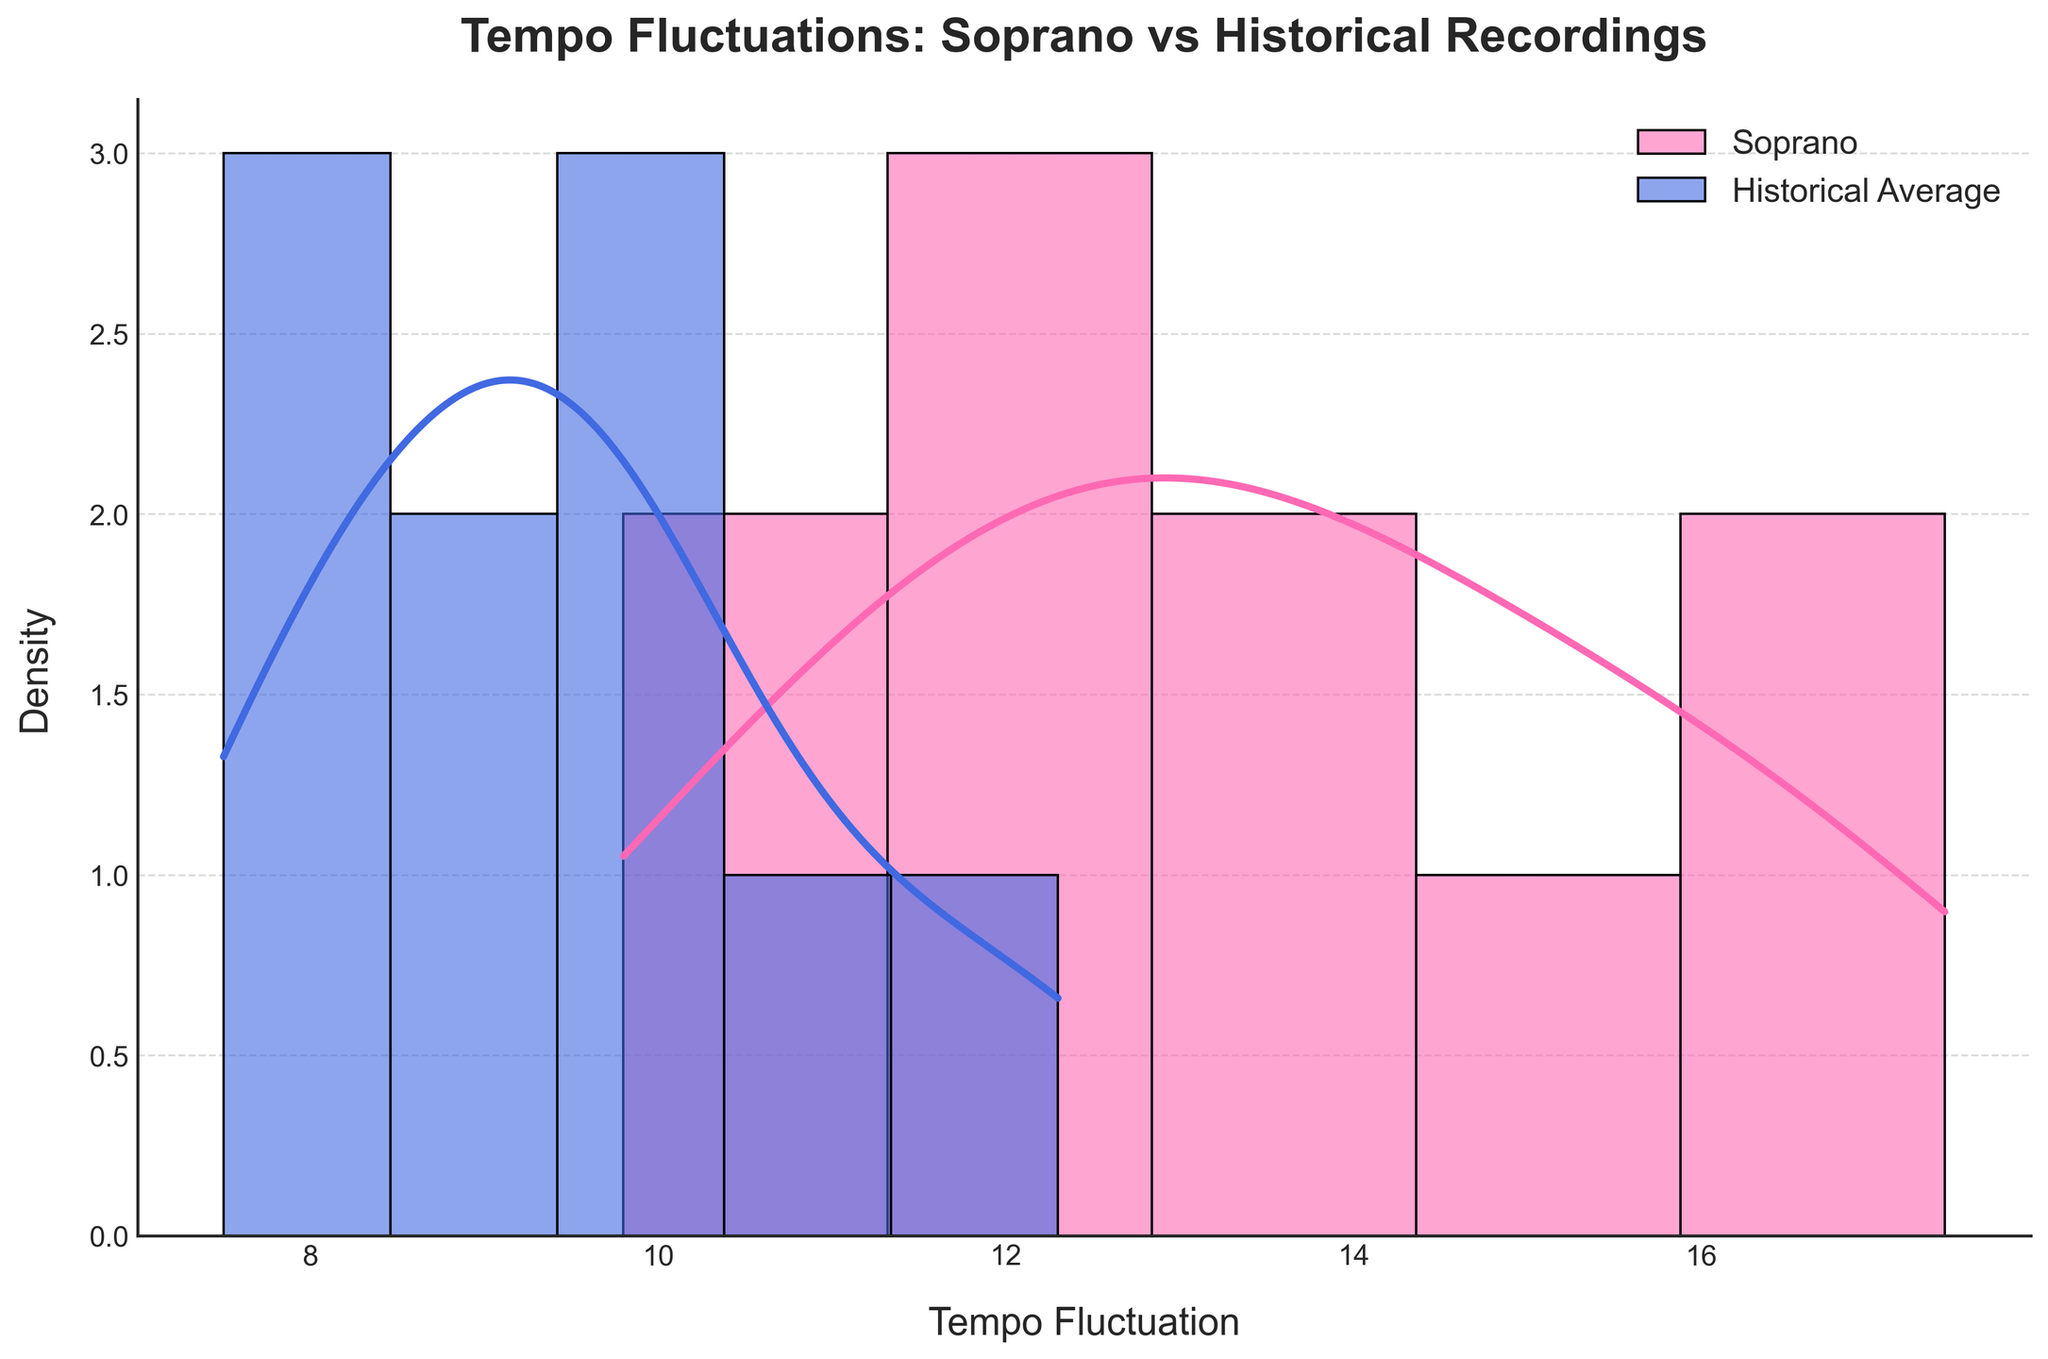What's the title of the plot? The title is located at the top of the plot. It reads, "Tempo Fluctuations: Soprano vs Historical Recordings"
Answer: Tempo Fluctuations: Soprano vs Historical Recordings Which color represents the Soprano Tempo Fluctuations? By observing the plot, the Soprano Tempo Fluctuations are represented by a pink color.
Answer: Pink What does the x-axis represent? The x-axis label is present beneath the horizontal axis in the plot. It is labeled as "Tempo Fluctuation".
Answer: Tempo Fluctuation Which dataset has a higher density towards larger tempo fluctuations? By looking at the density curves, the Soprano dataset (pink) generally shows a higher density towards larger tempo fluctuations when compared to the Historical Average (blue).
Answer: Soprano Is there any overlap between the KDE curves of Soprano and Historical Average? By examining the plot, one can see that there is indeed an overlap between the pink (Soprano) and blue (Historical Average) density curves.
Answer: Yes What is the general range of tempo fluctuations in the Soprano dataset? Checking the spread of the pink bars, the Soprano tempo fluctuations roughly range from around 10 to 17.4.
Answer: 10 to 17.4 What is the general range of the Historical Average tempo fluctuations? Observing the spread of the blue bars, the Historical Average tempo fluctuations range from approximately 7.5 to 12.3.
Answer: 7.5 to 12.3 Which aria had the largest tempo fluctuation in the soprano's interpretations? Observing the dataset, "Martern aller Arten" from The Abduction from the Seraglio had the largest tempo fluctuation at 17.4 in the soprano's interpretations.
Answer: "Martern aller Arten" (The Abduction from the Seraglio) How do the peak densities of Soprano and Historical Average compare? By looking at the peaks of the KDE curves, the Soprano's peak density is higher than that of the Historical Average, indicating more frequent higher fluctuations.
Answer: Soprano's peak density is higher Is the average tempo fluctuation of the soprano's interpretations higher than the historical average? The general position and density of the pink bars (soprano) being to the right of the blue bars (historical) indicates that the averages for soprano interpretations are higher.
Answer: Yes 